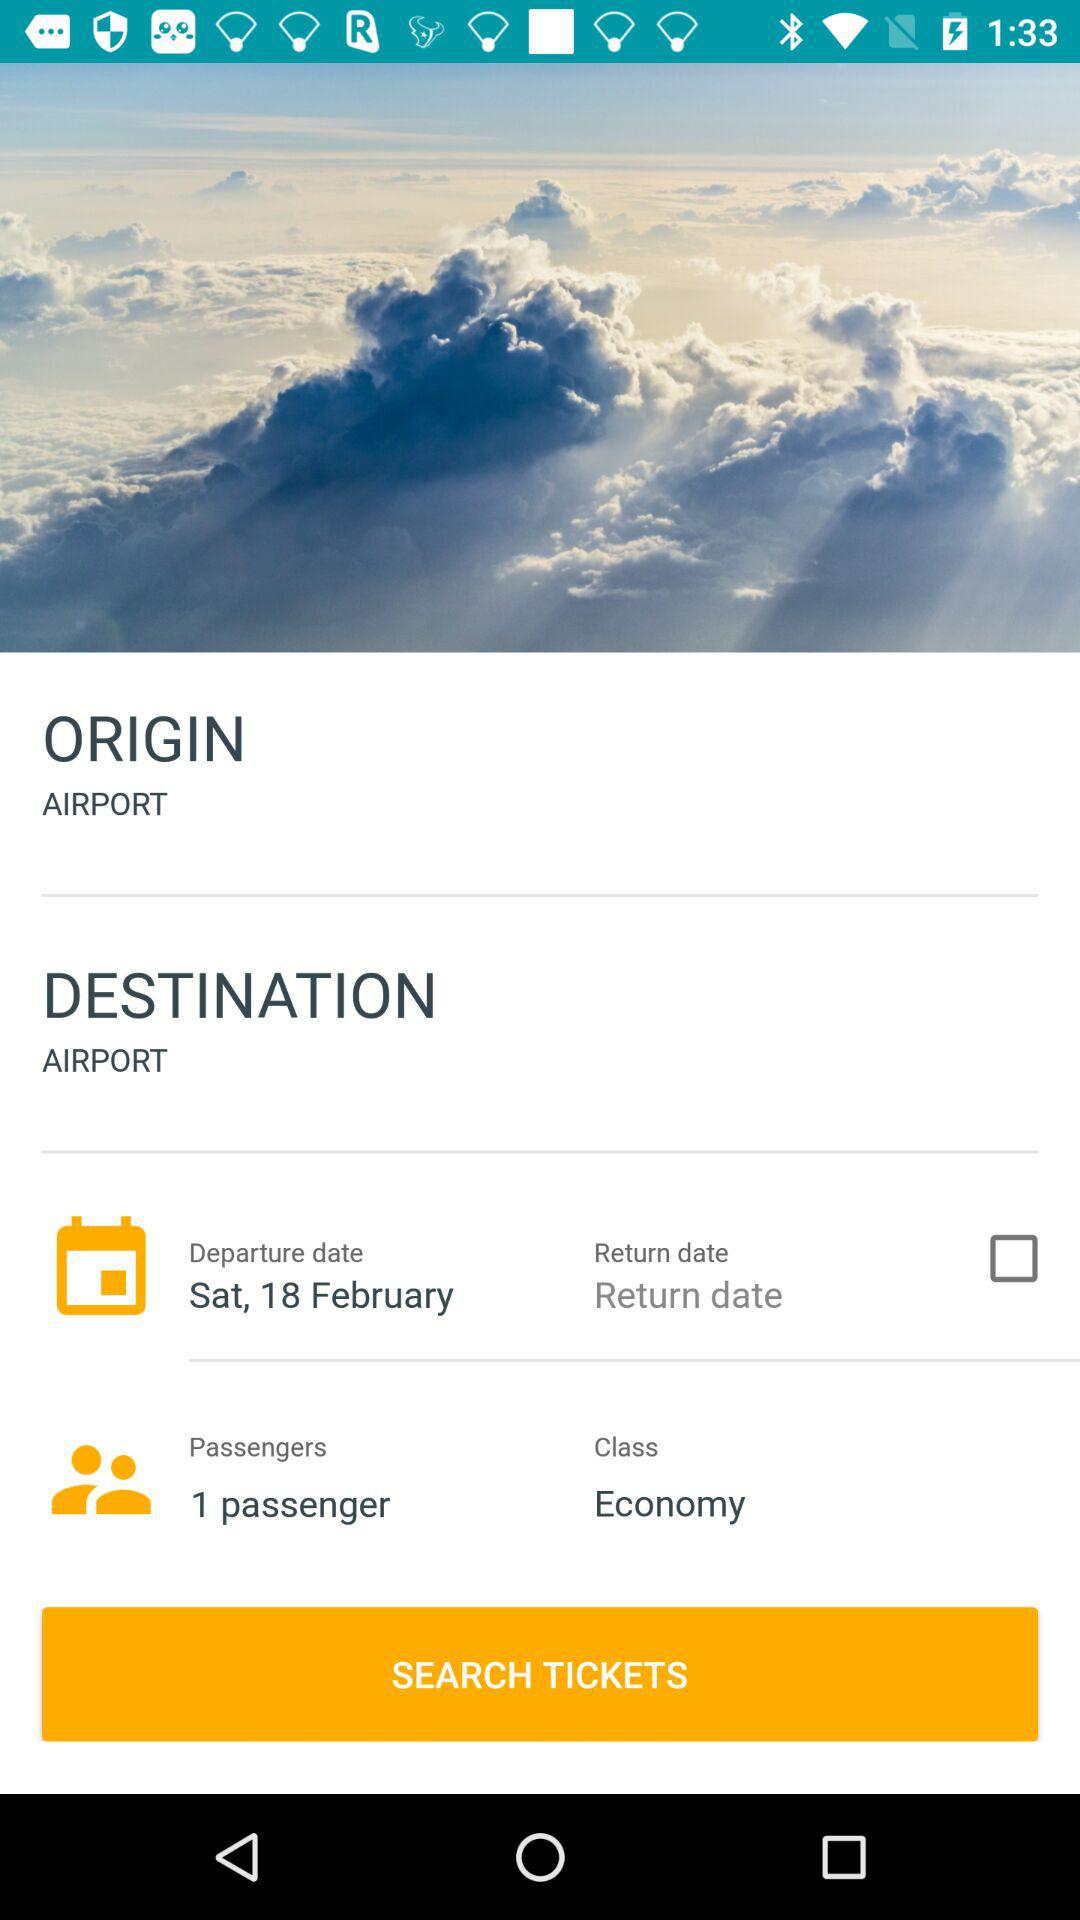What is the class? The class is "Economy". 